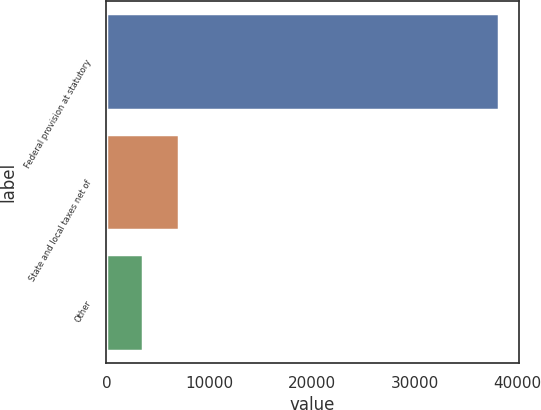Convert chart to OTSL. <chart><loc_0><loc_0><loc_500><loc_500><bar_chart><fcel>Federal provision at statutory<fcel>State and local taxes net of<fcel>Other<nl><fcel>38170<fcel>7089<fcel>3552<nl></chart> 